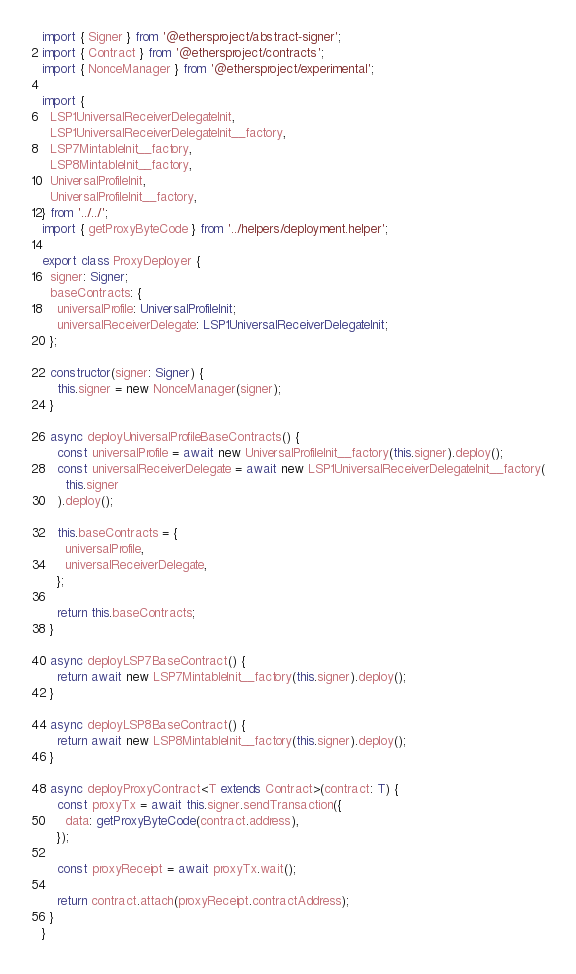Convert code to text. <code><loc_0><loc_0><loc_500><loc_500><_TypeScript_>import { Signer } from '@ethersproject/abstract-signer';
import { Contract } from '@ethersproject/contracts';
import { NonceManager } from '@ethersproject/experimental';

import {
  LSP1UniversalReceiverDelegateInit,
  LSP1UniversalReceiverDelegateInit__factory,
  LSP7MintableInit__factory,
  LSP8MintableInit__factory,
  UniversalProfileInit,
  UniversalProfileInit__factory,
} from '../../';
import { getProxyByteCode } from '../helpers/deployment.helper';

export class ProxyDeployer {
  signer: Signer;
  baseContracts: {
    universalProfile: UniversalProfileInit;
    universalReceiverDelegate: LSP1UniversalReceiverDelegateInit;
  };

  constructor(signer: Signer) {
    this.signer = new NonceManager(signer);
  }

  async deployUniversalProfileBaseContracts() {
    const universalProfile = await new UniversalProfileInit__factory(this.signer).deploy();
    const universalReceiverDelegate = await new LSP1UniversalReceiverDelegateInit__factory(
      this.signer
    ).deploy();

    this.baseContracts = {
      universalProfile,
      universalReceiverDelegate,
    };

    return this.baseContracts;
  }

  async deployLSP7BaseContract() {
    return await new LSP7MintableInit__factory(this.signer).deploy();
  }

  async deployLSP8BaseContract() {
    return await new LSP8MintableInit__factory(this.signer).deploy();
  }

  async deployProxyContract<T extends Contract>(contract: T) {
    const proxyTx = await this.signer.sendTransaction({
      data: getProxyByteCode(contract.address),
    });

    const proxyReceipt = await proxyTx.wait();

    return contract.attach(proxyReceipt.contractAddress);
  }
}
</code> 